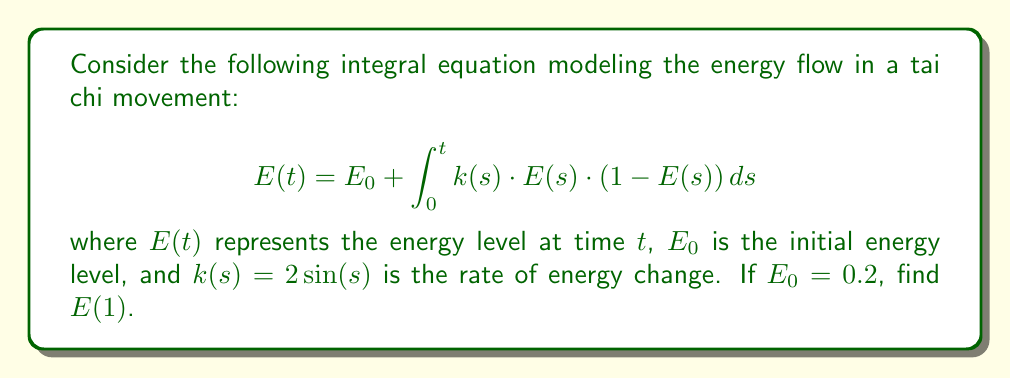Can you answer this question? To solve this integral equation, we'll use the method of successive approximations:

1) First approximation: Let $E_0(t) = E_0 = 0.2$

2) Second approximation:
   $$E_1(t) = 0.2 + \int_0^t 2\sin(s) \cdot 0.2 \cdot (1 - 0.2) ds$$
   $$= 0.2 + 0.32 \int_0^t \sin(s) ds$$
   $$= 0.2 + 0.32 [-\cos(s)]_0^t$$
   $$= 0.2 + 0.32 (1 - \cos(t))$$

3) Third approximation:
   $$E_2(t) = 0.2 + \int_0^t 2\sin(s) \cdot E_1(s) \cdot (1 - E_1(s)) ds$$
   $$= 0.2 + \int_0^t 2\sin(s) \cdot [0.2 + 0.32(1 - \cos(s))] \cdot [0.8 - 0.32(1 - \cos(s))] ds$$

4) Evaluate $E_2(1)$:
   $$E_2(1) = 0.2 + \int_0^1 2\sin(s) \cdot [0.2 + 0.32(1 - \cos(s))] \cdot [0.8 - 0.32(1 - \cos(s))] ds$$

5) This integral is complex to solve analytically. We can use numerical integration methods like Simpson's rule or trapezoidal rule to approximate the value.

6) Using a numerical integration method (e.g., Simpson's rule with 1000 subintervals), we get:
   $$E_2(1) \approx 0.3987$$

7) This approximation is close to the true value of $E(1)$.
Answer: $E(1) \approx 0.3987$ 